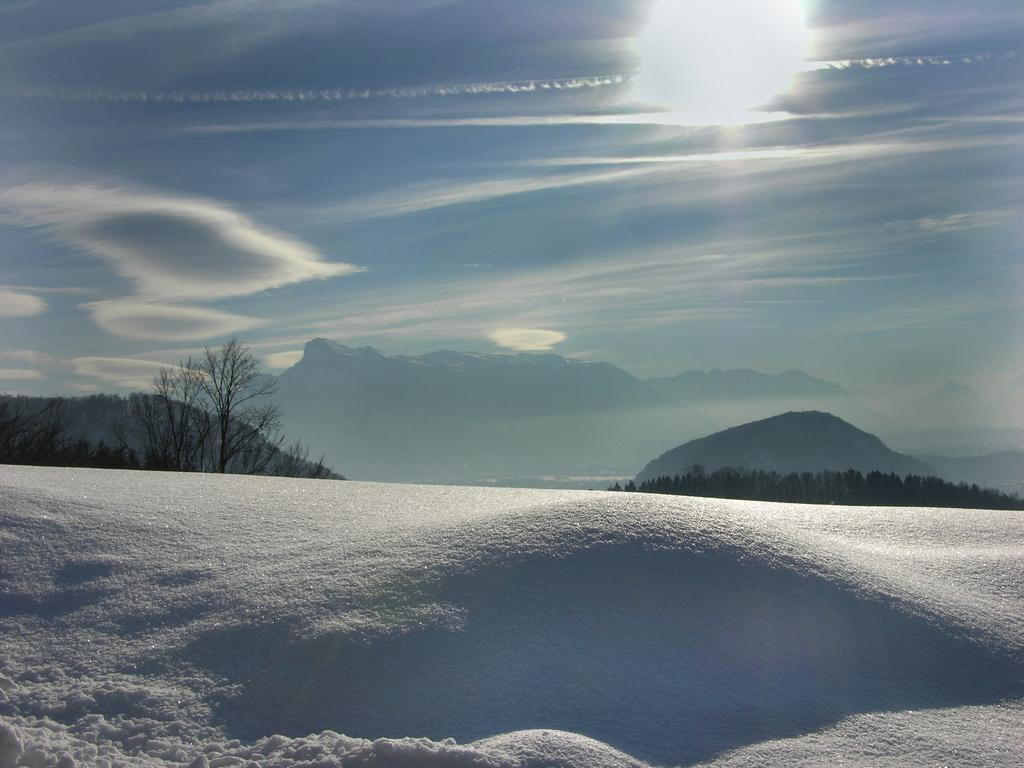What type of weather is depicted in the image? The sky is clear and sunny in the image, indicating a sunny day. What natural features can be seen in the image? There are trees and mountains in the image. What is the ground covered with in the image? The ground is covered with snow in the image. What part of the finger is visible in the image? There are no fingers present in the image; it features snow, trees, and mountains. 